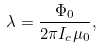<formula> <loc_0><loc_0><loc_500><loc_500>\lambda = \frac { \Phi _ { 0 } } { 2 \pi I _ { c } \mu _ { 0 } } ,</formula> 